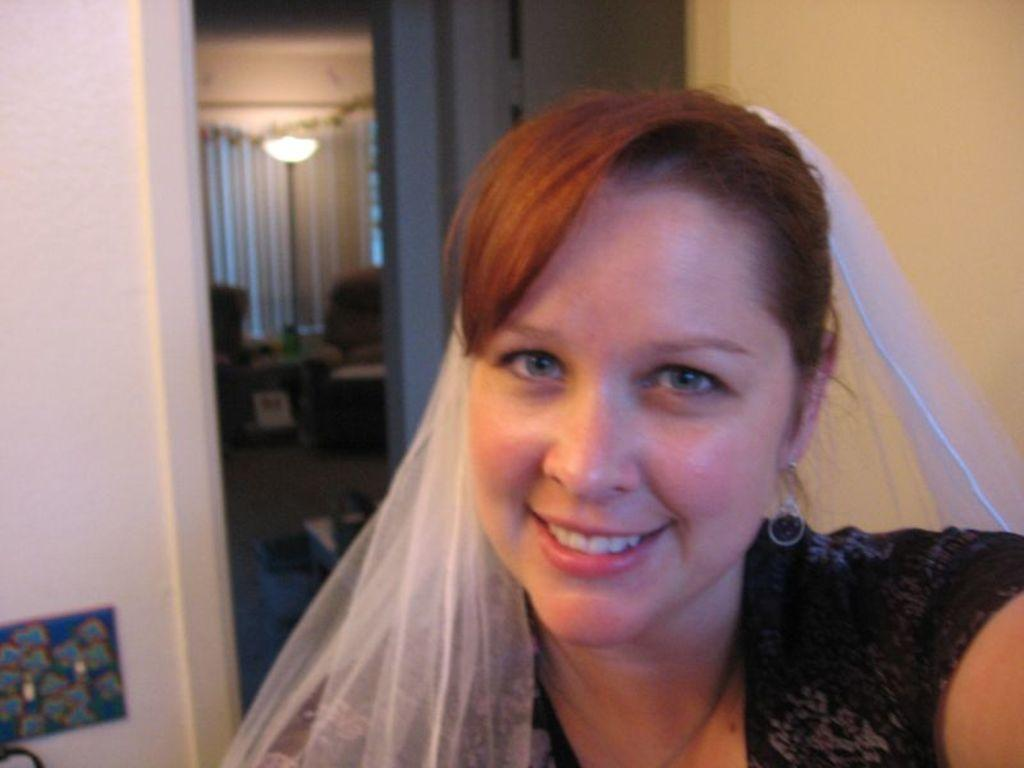Who is present in the image? There is a woman in the image. What is the woman doing in the image? The woman is laughing in the image. What can be seen in the background of the image? There is a wall and a door in the image. What type of furniture is present in the image? There are chairs present in the image. What can be used for illumination in the image? There are lights in the image. What is the woman's desire to battle in the image? There is no indication of a battle or any desire for one in the image; the woman is simply laughing. 